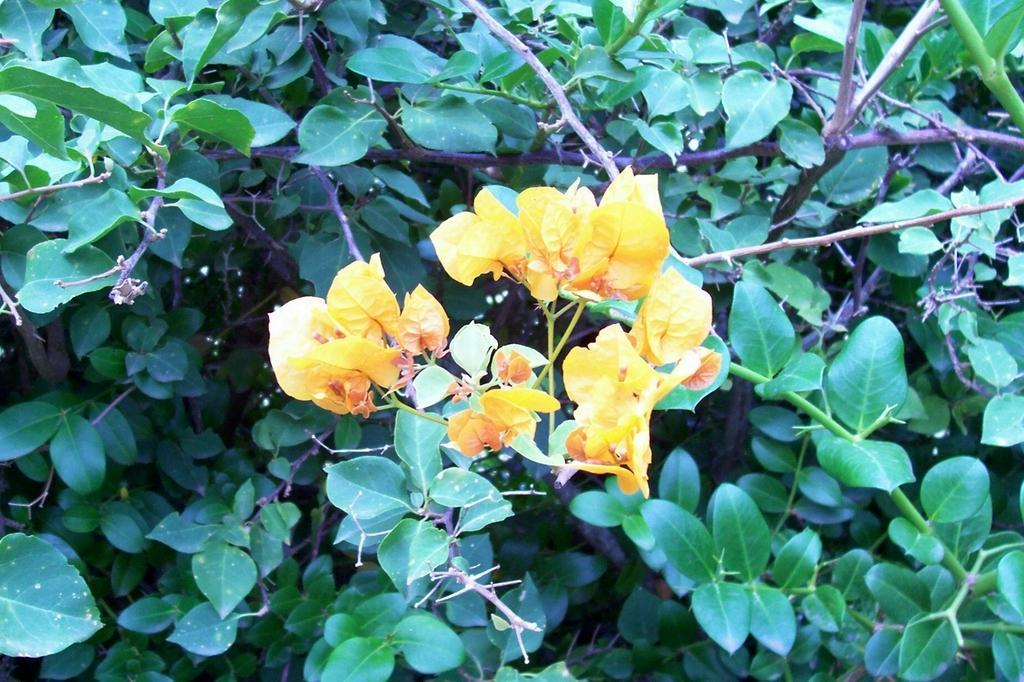Can you describe this image briefly? In this image there are small yellow colour flowers in the middle and there are green leaves around it. 